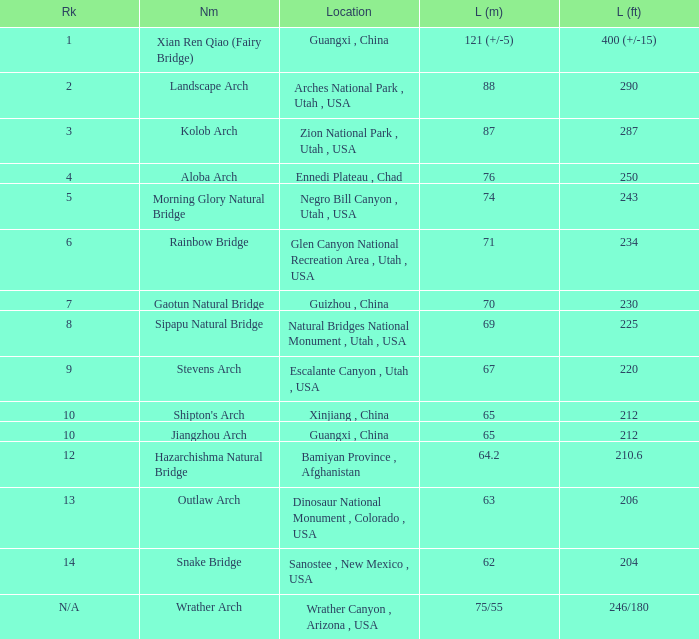Where is the longest arch with a length in meters of 63? Dinosaur National Monument , Colorado , USA. 